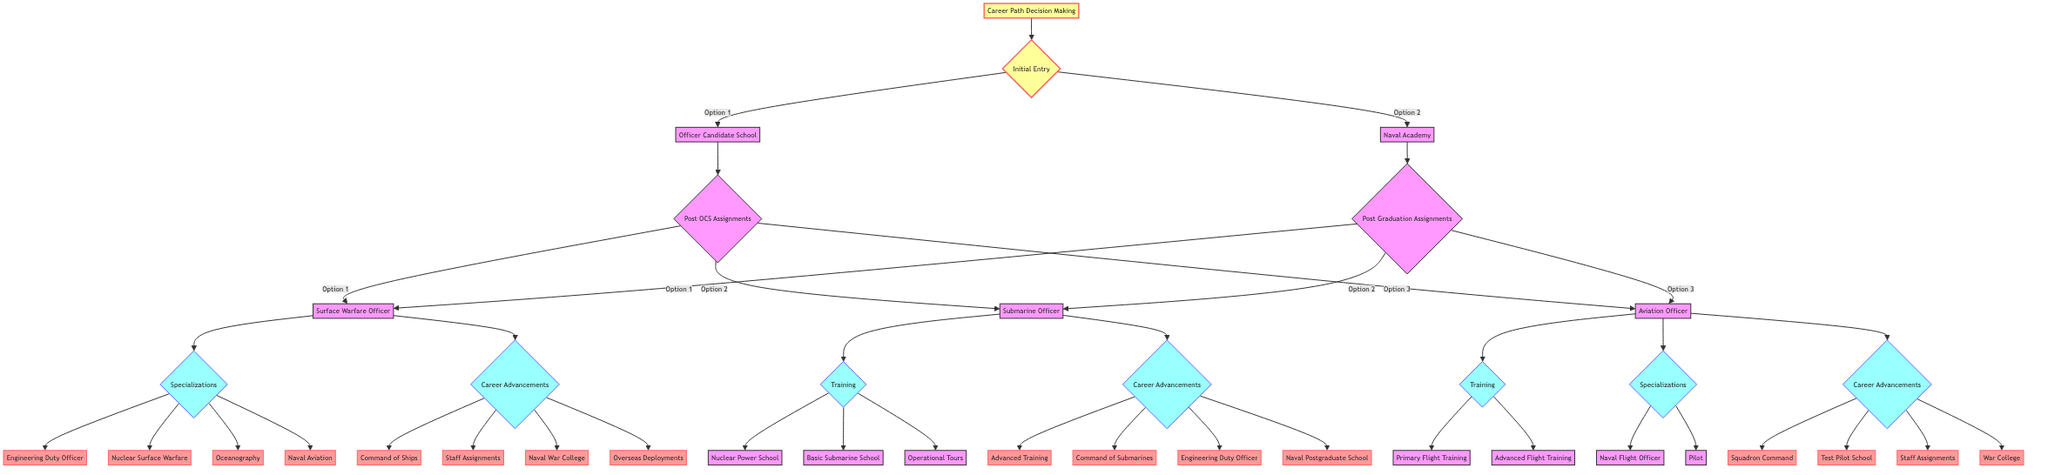What are the two initial entry options available for a naval career? The decision tree shows two initial entry options: Officer Candidate School and Naval Academy. This information can be found at the top level of the decision tree branching from the Initial Entry node.
Answer: Officer Candidate School, Naval Academy How many post-assignment options are available under Officer Candidate School? Under the Officer Candidate School node, there are three post-assignment options illustrated: Surface Warfare Officer, Submarine Officer, and Aviation Officer. Each option serves as a direct branch from the Post OCS Assignments node.
Answer: 3 What is one specialization option for a Surface Warfare Officer? The diagram indicates that one of the specialization options available for a Surface Warfare Officer is Engineering Duty Officer. This can be identified under the Specializations node connected after selecting Surface Warfare Officer.
Answer: Engineering Duty Officer Which training options are available for a Submarine Officer? The decision tree outlines three training options for a Submarine Officer. These options include Nuclear Power School, Basic Submarine School, and Operational Tours, all of which branch from the Training node after selecting Submarine Officer.
Answer: Nuclear Power School, Basic Submarine School, Operational Tours What are the career advancement options for an Aviation Officer? The diagram lists four career advancement options available for an Aviation Officer: Squadron Command, Test Pilot School, Staff Assignments, and War College. These options arise from the Career Advancements node after selecting Aviation Officer.
Answer: Squadron Command, Test Pilot School, Staff Assignments, War College If an officer starts at the Naval Academy, what is one path they can take after graduation? After graduation from the Naval Academy, an officer can choose to specialize as a Surface Warfare Officer, Submarine Officer, or Aviation Officer. This is based on the Post Graduation Assignments node branching from the Naval Academy, where all three options are the next steps.
Answer: Surface Warfare Officer, Submarine Officer, Aviation Officer Are there more specializations or career advancement options for a Surface Warfare Officer? A Surface Warfare Officer has four specialization options (Engineering Duty Officer, Nuclear Surface Warfare, Oceanography, and Naval Aviation) and four career advancement options (Command of Ships, Staff Assignments, Naval War College, and Overseas Deployments). By comparing the two sets of options, it can be concluded that they are equal in number.
Answer: Equal What options are listed under the Training node for an Aviation Officer? The Training node for an Aviation Officer includes two specific options: Primary Flight Training and Advanced Flight Training. These branch directly from the Training node following the selection of Aviation Officer.
Answer: Primary Flight Training, Advanced Flight Training 